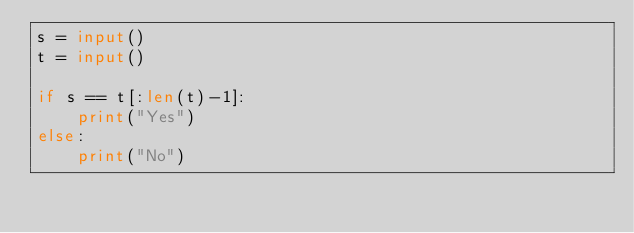Convert code to text. <code><loc_0><loc_0><loc_500><loc_500><_Python_>s = input()
t = input()

if s == t[:len(t)-1]:
    print("Yes")
else:
    print("No")</code> 